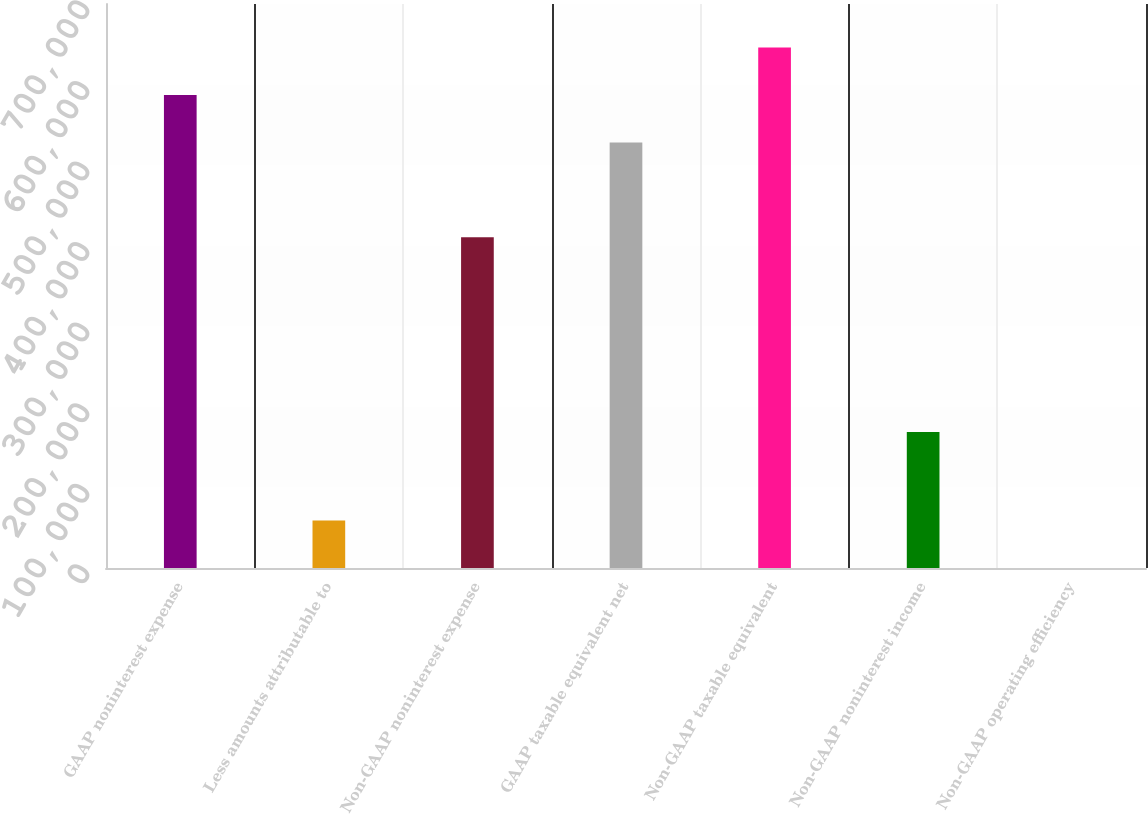Convert chart. <chart><loc_0><loc_0><loc_500><loc_500><bar_chart><fcel>GAAP noninterest expense<fcel>Less amounts attributable to<fcel>Non-GAAP noninterest expense<fcel>GAAP taxable equivalent net<fcel>Non-GAAP taxable equivalent<fcel>Non-GAAP noninterest income<fcel>Non-GAAP operating efficiency<nl><fcel>587090<fcel>58943<fcel>410470<fcel>528217<fcel>645963<fcel>168645<fcel>69.71<nl></chart> 